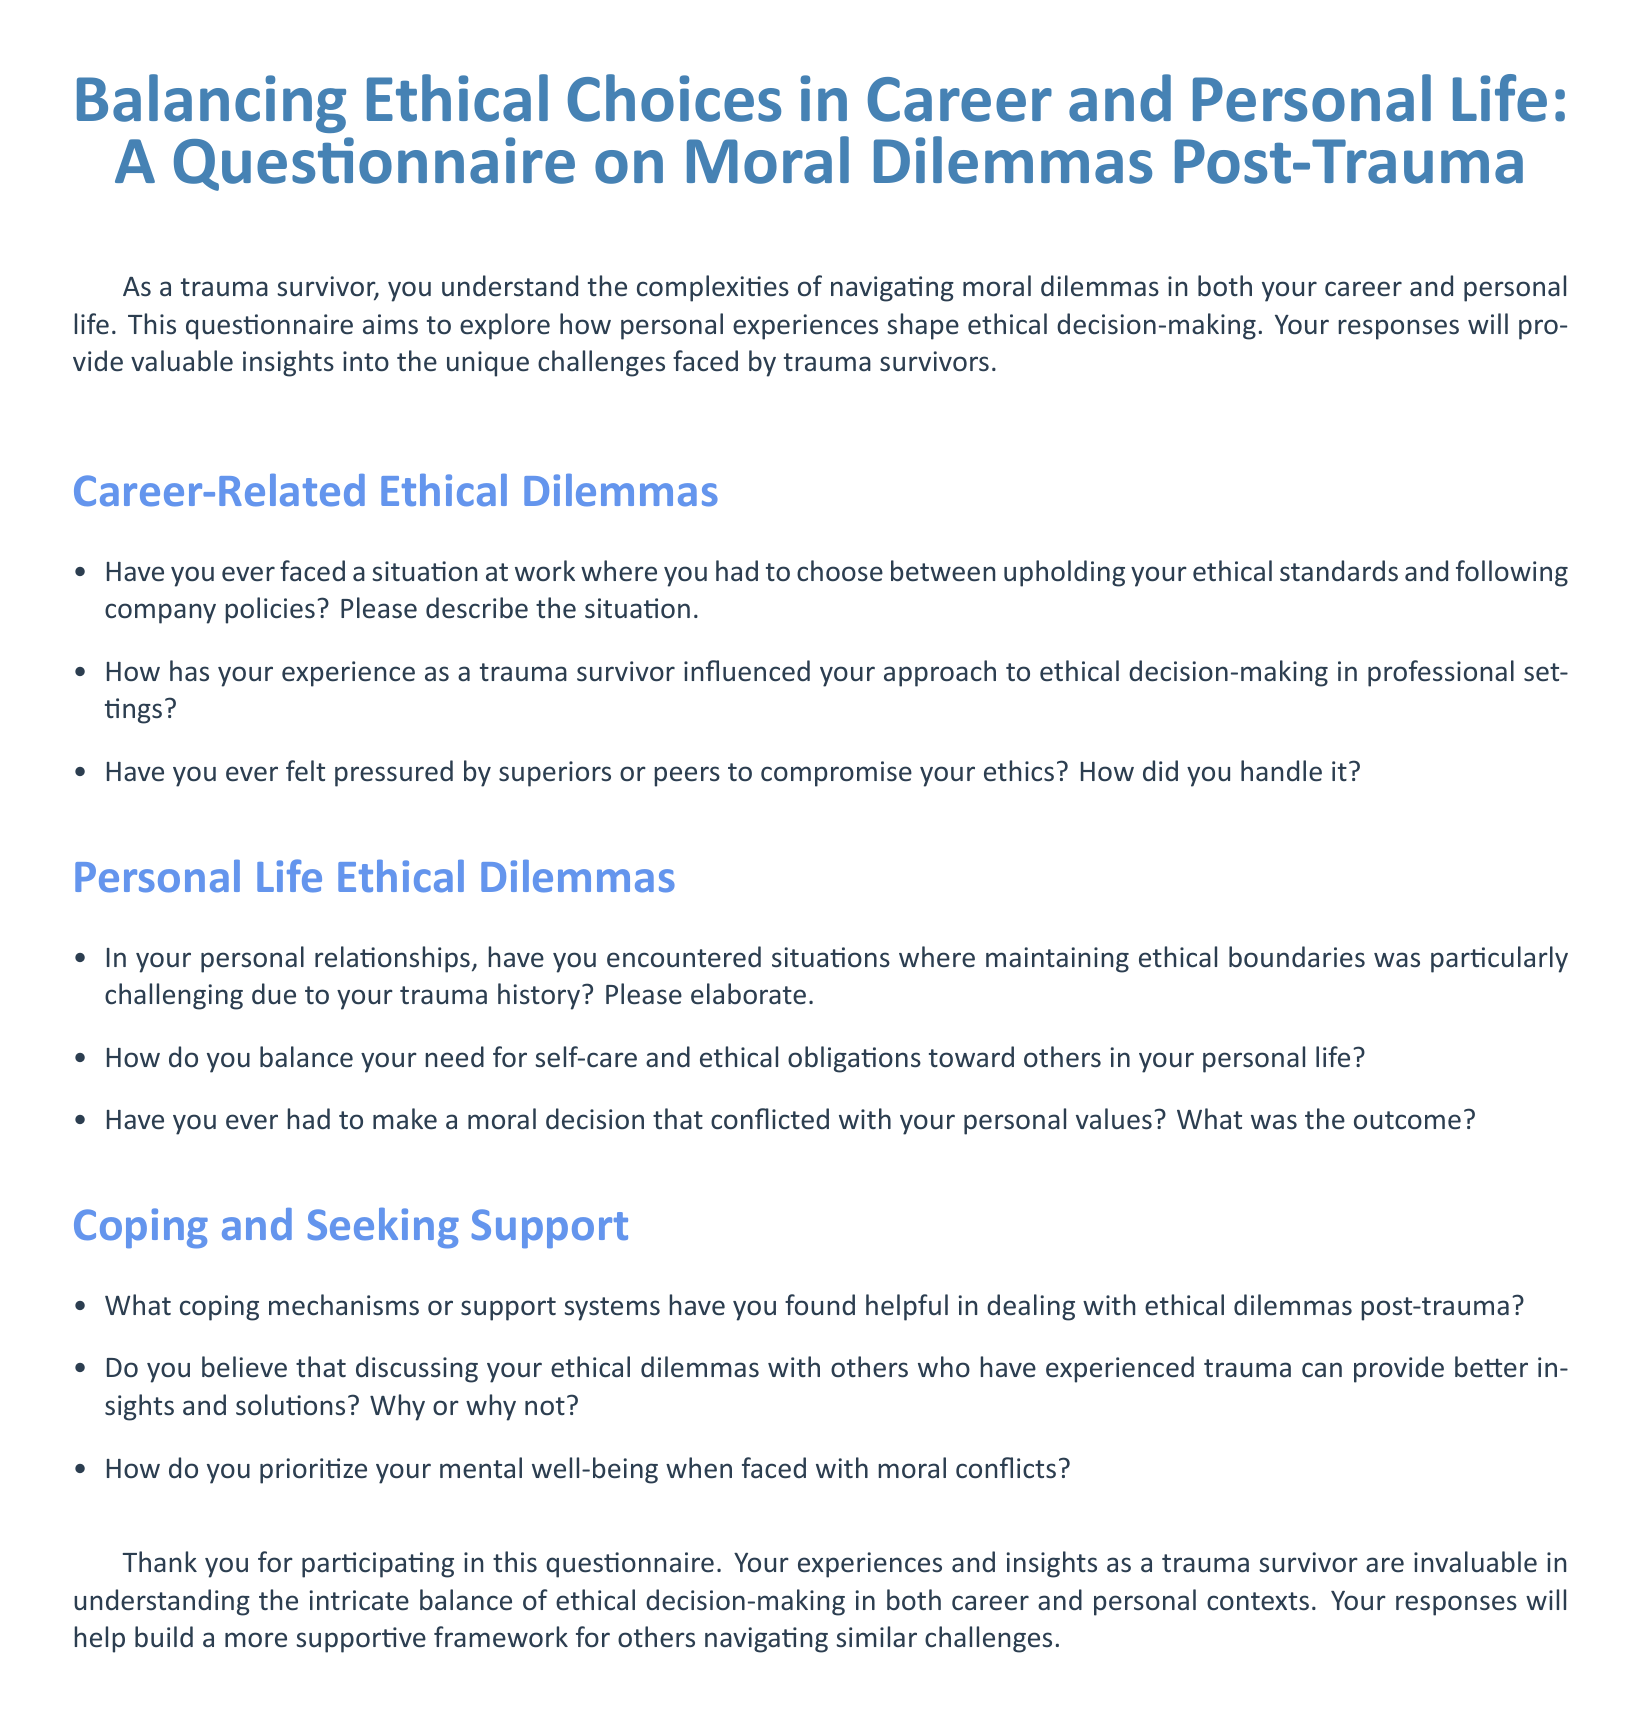What is the title of the document? The title is prominently displayed at the top of the document, which provides the main focus of the content.
Answer: Balancing Ethical Choices in Career and Personal Life: A Questionnaire on Moral Dilemmas Post-Trauma What is the purpose of the questionnaire? The purpose is stated in the introduction, indicating what the questionnaire aims to achieve through the responses.
Answer: To explore how personal experiences shape ethical decision-making How many sections are in the questionnaire? The document presents three distinct sections that categorize the questions addressed to participants.
Answer: Three What is the first question in the Career-Related Ethical Dilemmas section? The first question is listed first under the Career-Related Ethical Dilemmas section, seeking personal experiences.
Answer: Have you ever faced a situation at work where you had to choose between upholding your ethical standards and following company policies? What is the last section titled? The last section is labeled at the end of the document, summarizing the focus of questions related to coping and support.
Answer: Coping and Seeking Support How does the document emphasize the role of trauma in decision-making? The introduction outlines the context of the questionnaire as it pertains to trauma survivors, highlighting a unique perspective on ethical dilemmas.
Answer: It states that the questionnaire is for trauma survivors and discusses complexities they face 